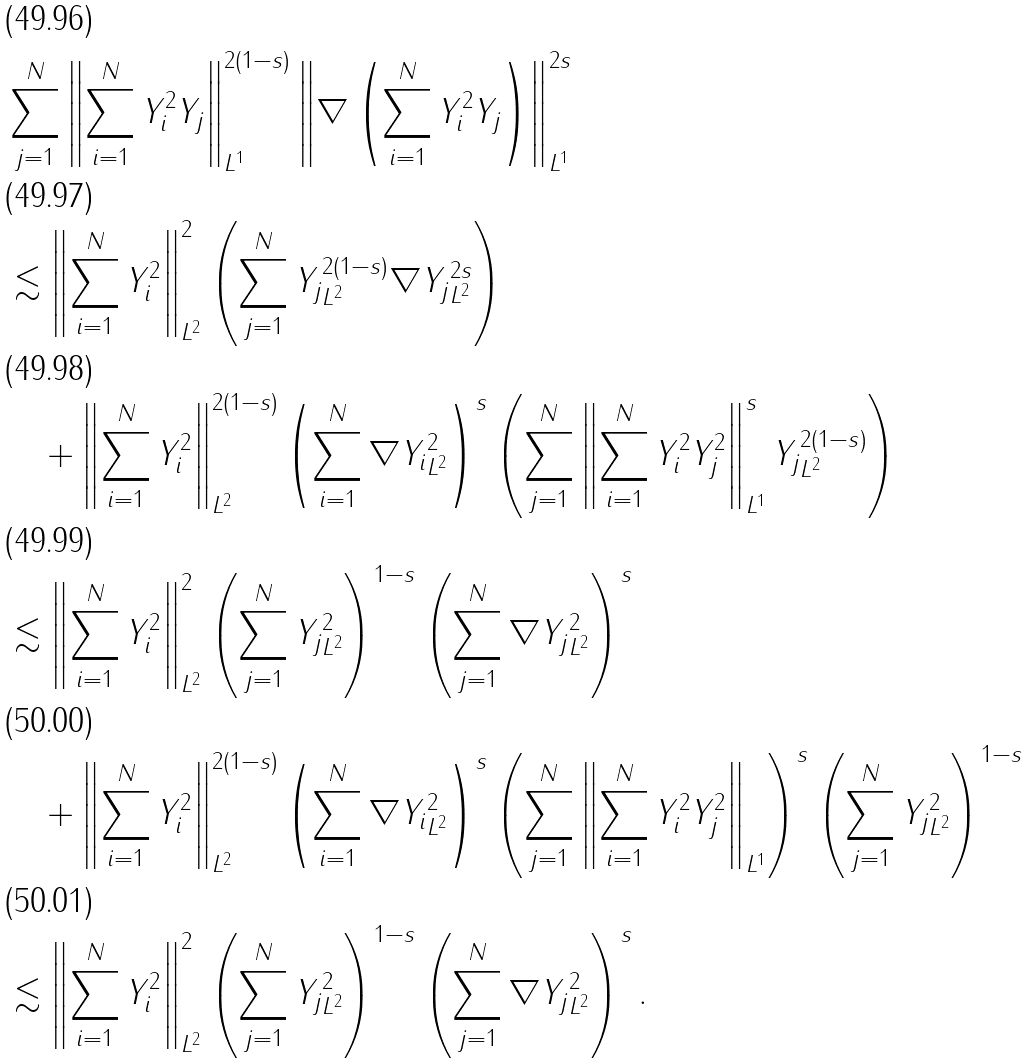<formula> <loc_0><loc_0><loc_500><loc_500>& \sum _ { j = 1 } ^ { N } \left \| \sum _ { i = 1 } ^ { N } Y _ { i } ^ { 2 } Y _ { j } \right \| _ { L ^ { 1 } } ^ { 2 ( 1 - s ) } \left \| \nabla \left ( \sum _ { i = 1 } ^ { N } Y _ { i } ^ { 2 } Y _ { j } \right ) \right \| _ { L ^ { 1 } } ^ { 2 s } \\ & \lesssim \left \| \sum _ { i = 1 } ^ { N } Y _ { i } ^ { 2 } \right \| _ { L ^ { 2 } } ^ { 2 } \left ( \sum _ { j = 1 } ^ { N } \| Y _ { j } \| ^ { 2 ( 1 - s ) } _ { L ^ { 2 } } \| \nabla Y _ { j } \| _ { L ^ { 2 } } ^ { 2 s } \right ) \\ & \quad + \left \| \sum _ { i = 1 } ^ { N } Y _ { i } ^ { 2 } \right \| _ { L ^ { 2 } } ^ { 2 ( 1 - s ) } \left ( \sum _ { i = 1 } ^ { N } \| \nabla Y _ { i } \| _ { L ^ { 2 } } ^ { 2 } \right ) ^ { s } \left ( \sum _ { j = 1 } ^ { N } \left \| \sum _ { i = 1 } ^ { N } Y _ { i } ^ { 2 } Y _ { j } ^ { 2 } \right \| _ { L ^ { 1 } } ^ { s } \| Y _ { j } \| _ { L ^ { 2 } } ^ { 2 ( 1 - s ) } \right ) \\ & \lesssim \left \| \sum _ { i = 1 } ^ { N } Y _ { i } ^ { 2 } \right \| _ { L ^ { 2 } } ^ { 2 } \left ( \sum _ { j = 1 } ^ { N } \| Y _ { j } \| ^ { 2 } _ { L ^ { 2 } } \right ) ^ { 1 - s } \left ( \sum _ { j = 1 } ^ { N } \| \nabla Y _ { j } \| _ { L ^ { 2 } } ^ { 2 } \right ) ^ { s } \\ & \quad + \left \| \sum _ { i = 1 } ^ { N } Y _ { i } ^ { 2 } \right \| _ { L ^ { 2 } } ^ { 2 ( 1 - s ) } \left ( \sum _ { i = 1 } ^ { N } \| \nabla Y _ { i } \| _ { L ^ { 2 } } ^ { 2 } \right ) ^ { s } \left ( \sum _ { j = 1 } ^ { N } \left \| \sum _ { i = 1 } ^ { N } Y _ { i } ^ { 2 } Y _ { j } ^ { 2 } \right \| _ { L ^ { 1 } } \right ) ^ { s } \left ( \sum _ { j = 1 } ^ { N } \| Y _ { j } \| _ { L ^ { 2 } } ^ { 2 } \right ) ^ { 1 - s } \\ & \lesssim \left \| \sum _ { i = 1 } ^ { N } Y _ { i } ^ { 2 } \right \| _ { L ^ { 2 } } ^ { 2 } \left ( \sum _ { j = 1 } ^ { N } \| Y _ { j } \| ^ { 2 } _ { L ^ { 2 } } \right ) ^ { 1 - s } \left ( \sum _ { j = 1 } ^ { N } \| \nabla Y _ { j } \| _ { L ^ { 2 } } ^ { 2 } \right ) ^ { s } .</formula> 